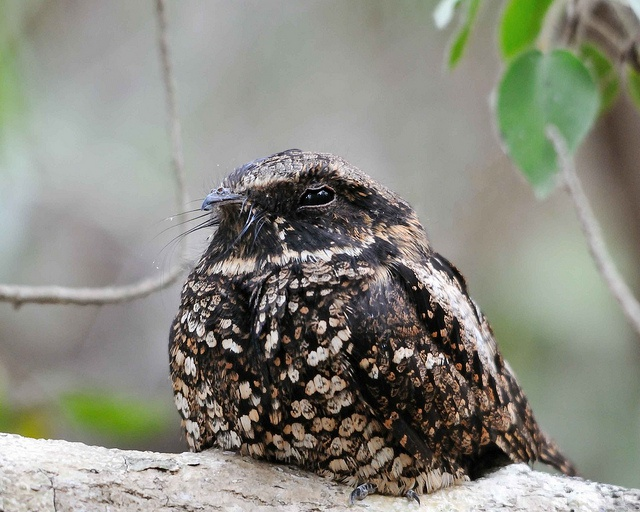Describe the objects in this image and their specific colors. I can see a bird in darkgray, black, gray, and lightgray tones in this image. 